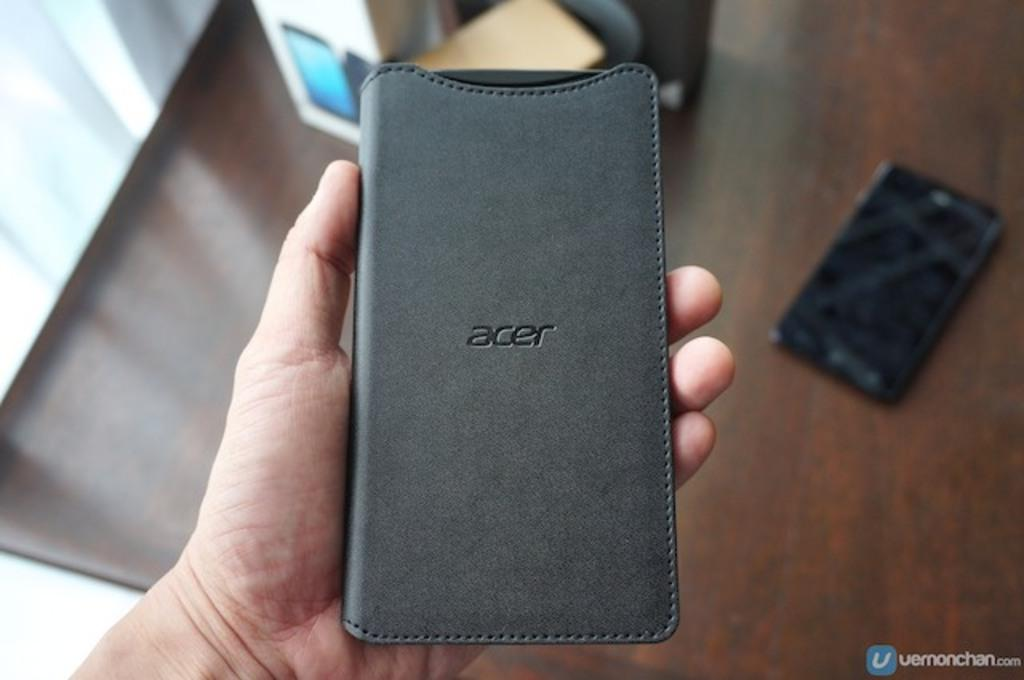<image>
Summarize the visual content of the image. A hand holding a cell phone showing the back of it that says acer on it. 